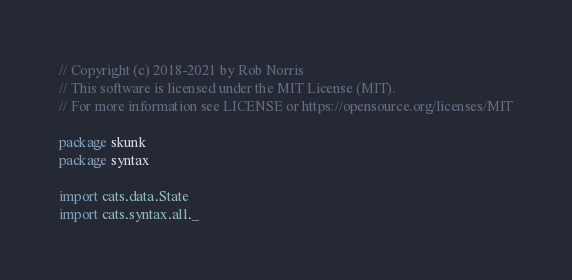<code> <loc_0><loc_0><loc_500><loc_500><_Scala_>// Copyright (c) 2018-2021 by Rob Norris
// This software is licensed under the MIT License (MIT).
// For more information see LICENSE or https://opensource.org/licenses/MIT

package skunk
package syntax

import cats.data.State
import cats.syntax.all._</code> 